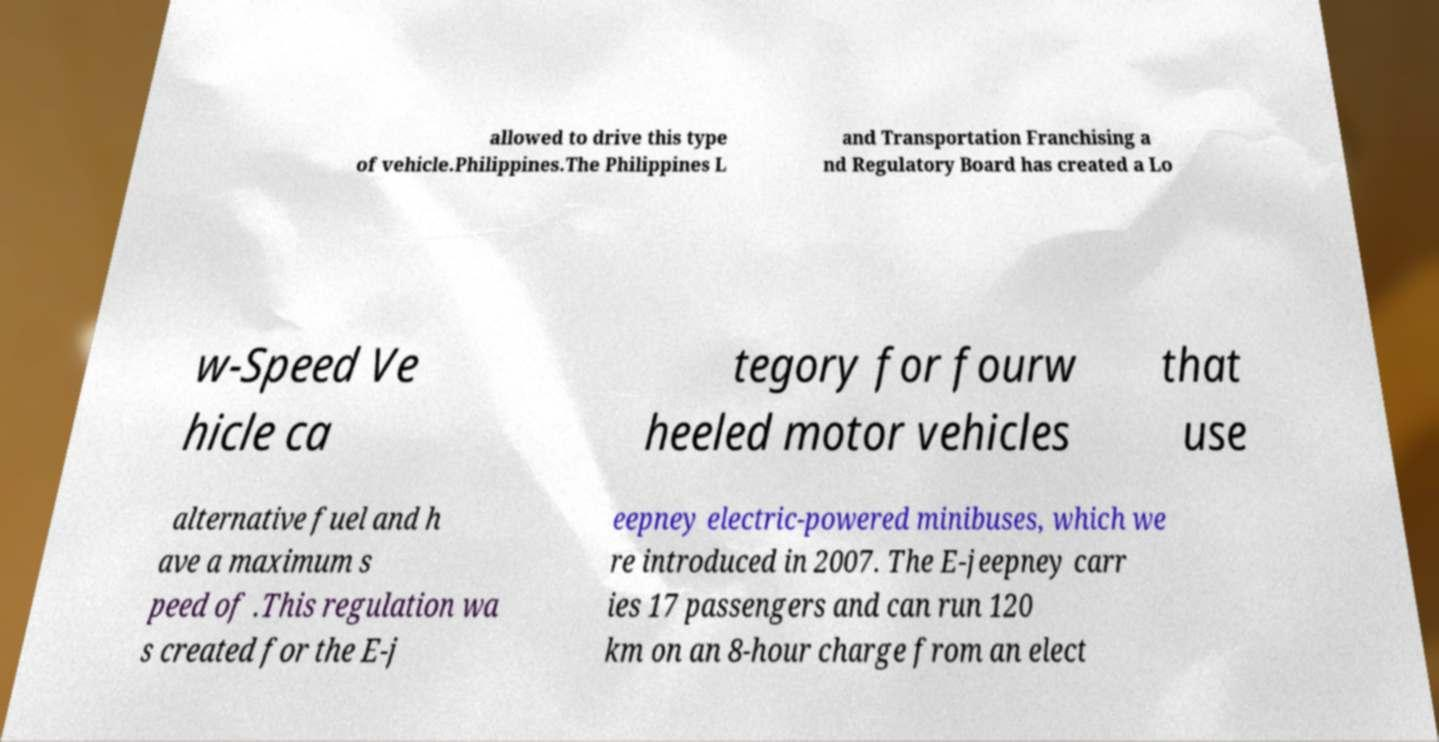What messages or text are displayed in this image? I need them in a readable, typed format. allowed to drive this type of vehicle.Philippines.The Philippines L and Transportation Franchising a nd Regulatory Board has created a Lo w-Speed Ve hicle ca tegory for fourw heeled motor vehicles that use alternative fuel and h ave a maximum s peed of .This regulation wa s created for the E-j eepney electric-powered minibuses, which we re introduced in 2007. The E-jeepney carr ies 17 passengers and can run 120 km on an 8-hour charge from an elect 